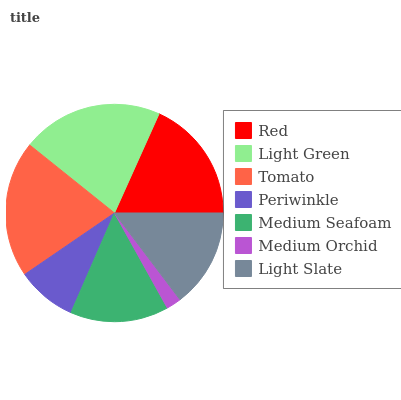Is Medium Orchid the minimum?
Answer yes or no. Yes. Is Light Green the maximum?
Answer yes or no. Yes. Is Tomato the minimum?
Answer yes or no. No. Is Tomato the maximum?
Answer yes or no. No. Is Light Green greater than Tomato?
Answer yes or no. Yes. Is Tomato less than Light Green?
Answer yes or no. Yes. Is Tomato greater than Light Green?
Answer yes or no. No. Is Light Green less than Tomato?
Answer yes or no. No. Is Light Slate the high median?
Answer yes or no. Yes. Is Light Slate the low median?
Answer yes or no. Yes. Is Tomato the high median?
Answer yes or no. No. Is Medium Orchid the low median?
Answer yes or no. No. 